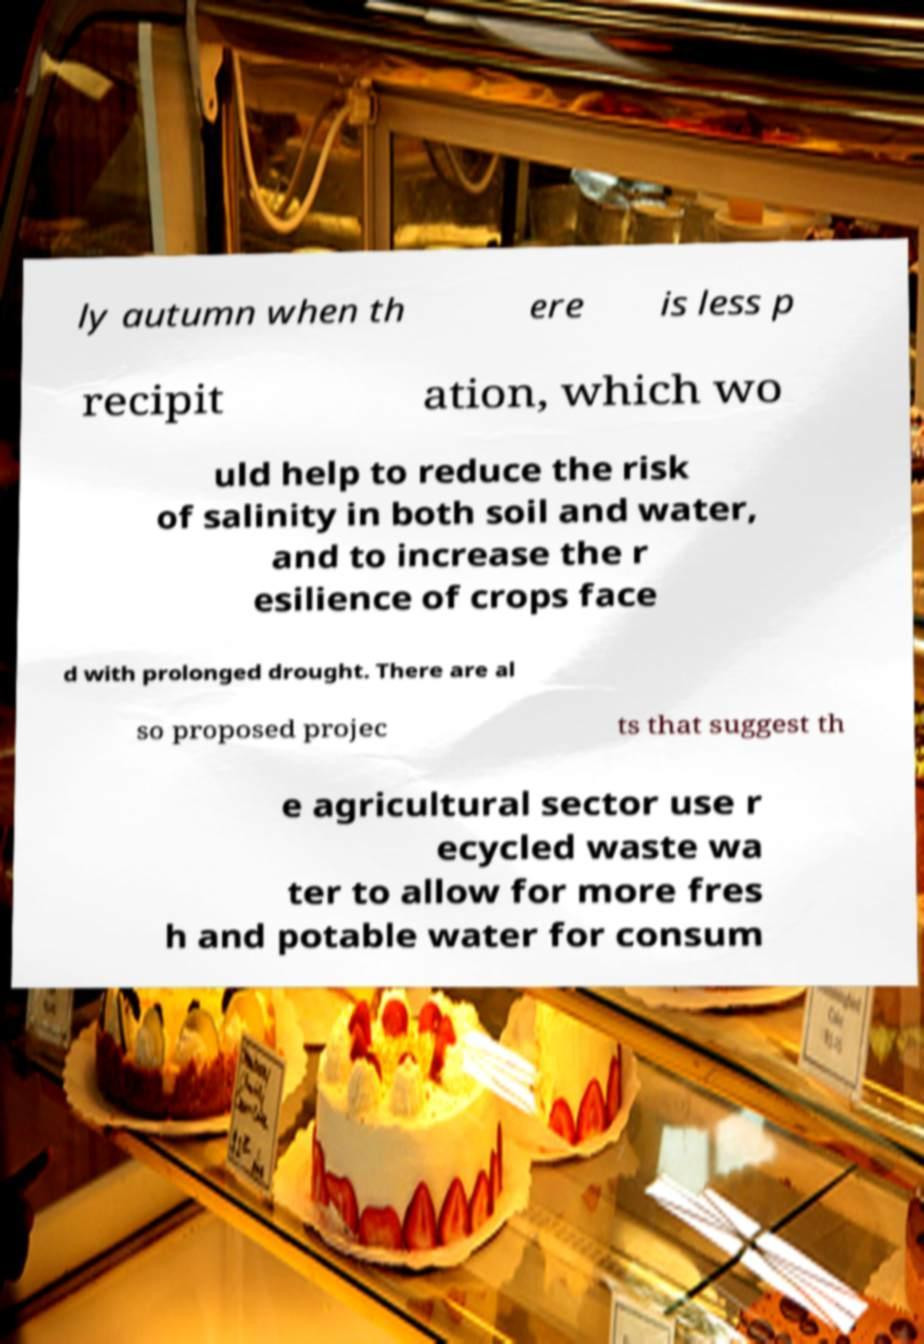Please identify and transcribe the text found in this image. ly autumn when th ere is less p recipit ation, which wo uld help to reduce the risk of salinity in both soil and water, and to increase the r esilience of crops face d with prolonged drought. There are al so proposed projec ts that suggest th e agricultural sector use r ecycled waste wa ter to allow for more fres h and potable water for consum 